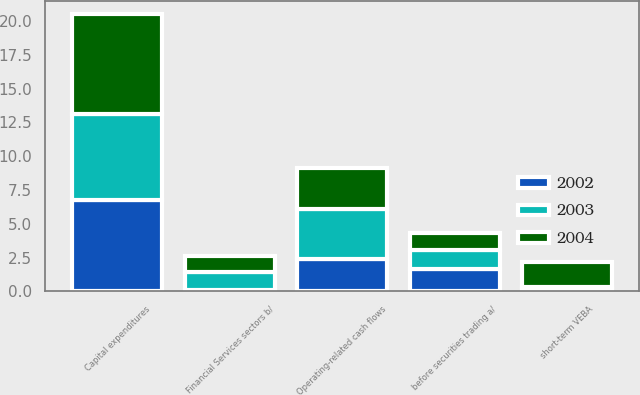<chart> <loc_0><loc_0><loc_500><loc_500><stacked_bar_chart><ecel><fcel>before securities trading a/<fcel>Capital expenditures<fcel>Financial Services sectors b/<fcel>short-term VEBA<fcel>Operating-related cash flows<nl><fcel>2003<fcel>1.4<fcel>6.3<fcel>1.3<fcel>0.1<fcel>3.7<nl><fcel>2004<fcel>1.3<fcel>7.4<fcel>1.2<fcel>1.9<fcel>3<nl><fcel>2002<fcel>1.65<fcel>6.8<fcel>0.1<fcel>0.2<fcel>2.4<nl></chart> 